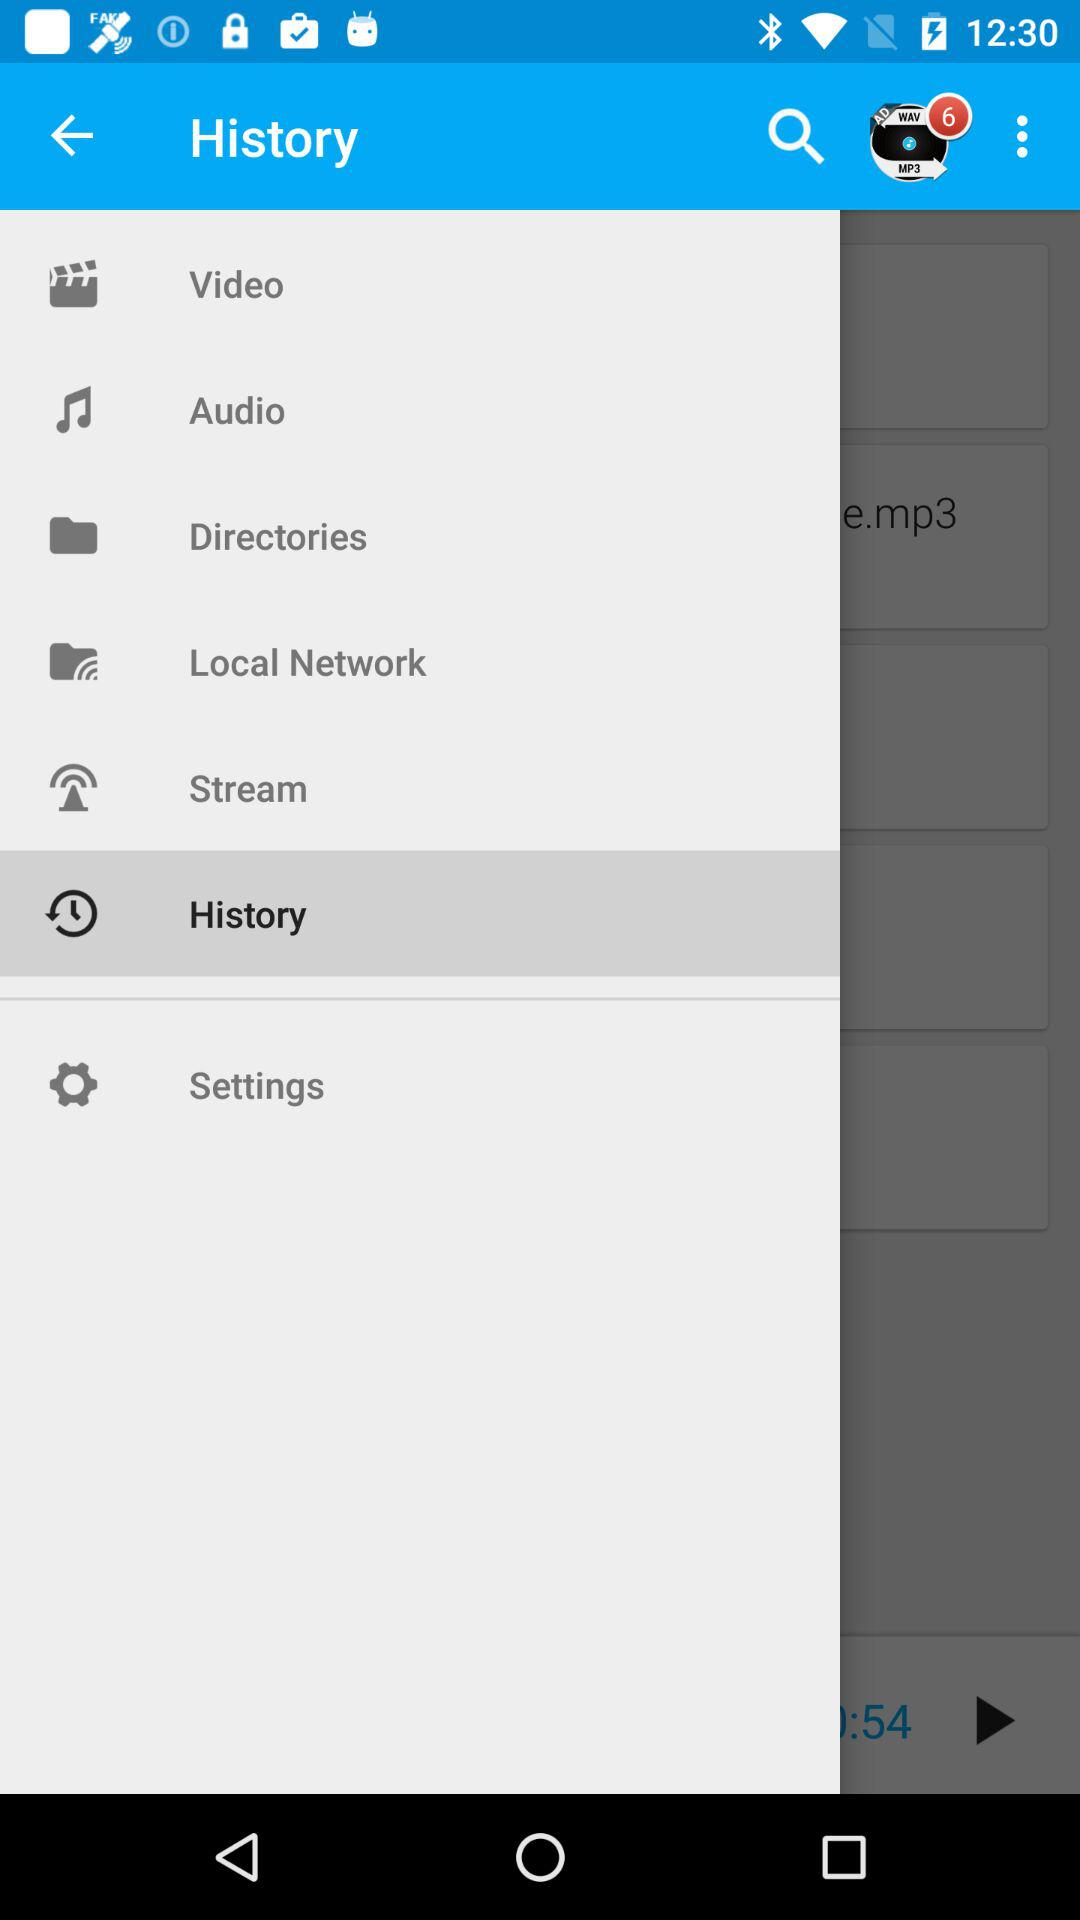How many notifications are pending? There are six pending notifications. 